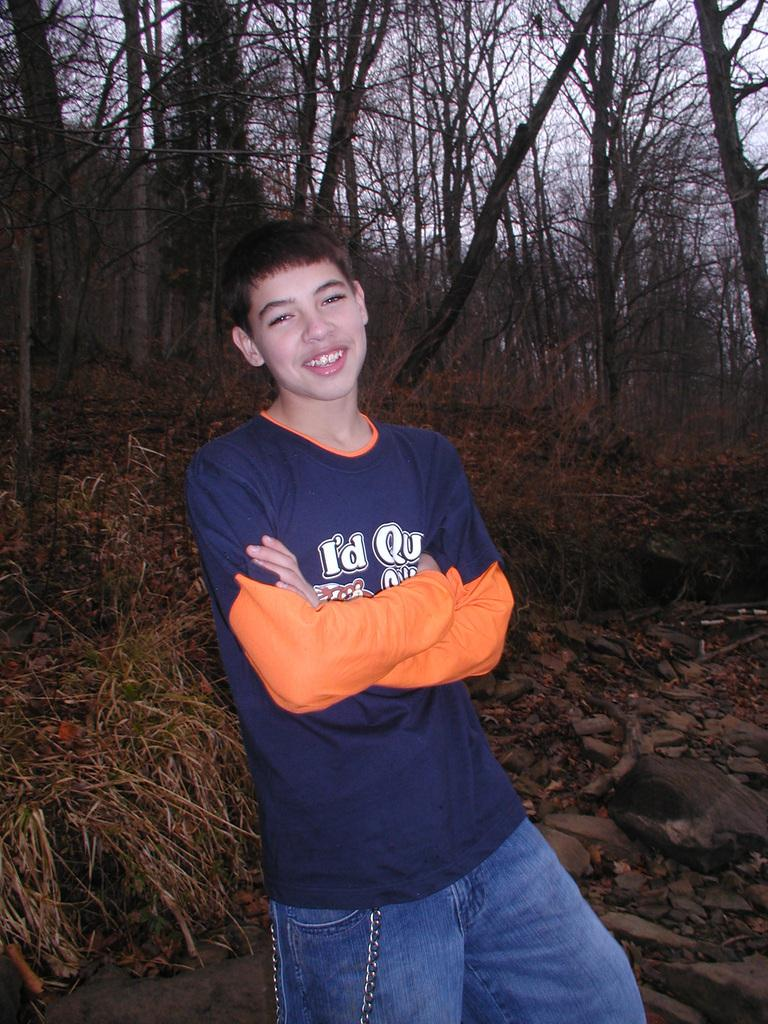<image>
Give a short and clear explanation of the subsequent image. A boy wearing a shirt with a slogan that starts with "I'd" crosses his arms and smiles. 